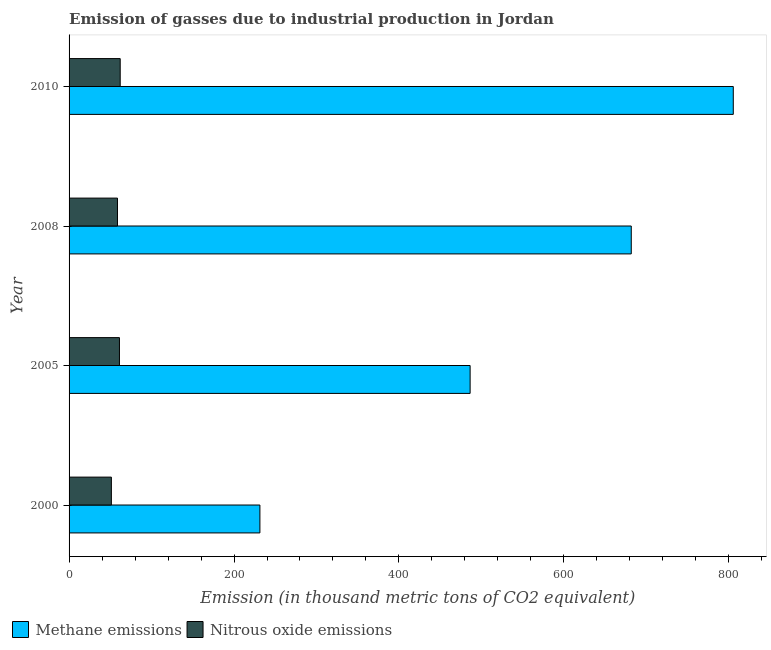How many groups of bars are there?
Your answer should be very brief. 4. Are the number of bars per tick equal to the number of legend labels?
Offer a terse response. Yes. How many bars are there on the 4th tick from the bottom?
Keep it short and to the point. 2. In how many cases, is the number of bars for a given year not equal to the number of legend labels?
Your answer should be compact. 0. What is the amount of methane emissions in 2000?
Your answer should be very brief. 231.4. Across all years, what is the maximum amount of nitrous oxide emissions?
Ensure brevity in your answer.  62. Across all years, what is the minimum amount of methane emissions?
Offer a terse response. 231.4. In which year was the amount of nitrous oxide emissions maximum?
Ensure brevity in your answer.  2010. What is the total amount of nitrous oxide emissions in the graph?
Your response must be concise. 233.1. What is the difference between the amount of nitrous oxide emissions in 2008 and the amount of methane emissions in 2010?
Provide a succinct answer. -746.7. What is the average amount of nitrous oxide emissions per year?
Give a very brief answer. 58.27. In the year 2005, what is the difference between the amount of nitrous oxide emissions and amount of methane emissions?
Your answer should be compact. -425.2. In how many years, is the amount of nitrous oxide emissions greater than 600 thousand metric tons?
Provide a succinct answer. 0. What is the ratio of the amount of methane emissions in 2005 to that in 2008?
Your answer should be compact. 0.71. Is the difference between the amount of methane emissions in 2000 and 2008 greater than the difference between the amount of nitrous oxide emissions in 2000 and 2008?
Your response must be concise. No. What is the difference between the highest and the lowest amount of methane emissions?
Your answer should be very brief. 574. In how many years, is the amount of methane emissions greater than the average amount of methane emissions taken over all years?
Your answer should be very brief. 2. Is the sum of the amount of nitrous oxide emissions in 2005 and 2008 greater than the maximum amount of methane emissions across all years?
Your response must be concise. No. What does the 1st bar from the top in 2005 represents?
Provide a succinct answer. Nitrous oxide emissions. What does the 2nd bar from the bottom in 2000 represents?
Provide a succinct answer. Nitrous oxide emissions. What is the difference between two consecutive major ticks on the X-axis?
Your response must be concise. 200. Does the graph contain any zero values?
Your answer should be very brief. No. How many legend labels are there?
Provide a short and direct response. 2. What is the title of the graph?
Offer a terse response. Emission of gasses due to industrial production in Jordan. Does "Chemicals" appear as one of the legend labels in the graph?
Your answer should be very brief. No. What is the label or title of the X-axis?
Your response must be concise. Emission (in thousand metric tons of CO2 equivalent). What is the Emission (in thousand metric tons of CO2 equivalent) of Methane emissions in 2000?
Offer a terse response. 231.4. What is the Emission (in thousand metric tons of CO2 equivalent) of Nitrous oxide emissions in 2000?
Offer a very short reply. 51.3. What is the Emission (in thousand metric tons of CO2 equivalent) of Methane emissions in 2005?
Give a very brief answer. 486.3. What is the Emission (in thousand metric tons of CO2 equivalent) in Nitrous oxide emissions in 2005?
Offer a very short reply. 61.1. What is the Emission (in thousand metric tons of CO2 equivalent) in Methane emissions in 2008?
Offer a very short reply. 681.7. What is the Emission (in thousand metric tons of CO2 equivalent) of Nitrous oxide emissions in 2008?
Your response must be concise. 58.7. What is the Emission (in thousand metric tons of CO2 equivalent) of Methane emissions in 2010?
Your answer should be very brief. 805.4. What is the Emission (in thousand metric tons of CO2 equivalent) of Nitrous oxide emissions in 2010?
Your answer should be very brief. 62. Across all years, what is the maximum Emission (in thousand metric tons of CO2 equivalent) in Methane emissions?
Make the answer very short. 805.4. Across all years, what is the minimum Emission (in thousand metric tons of CO2 equivalent) of Methane emissions?
Ensure brevity in your answer.  231.4. Across all years, what is the minimum Emission (in thousand metric tons of CO2 equivalent) of Nitrous oxide emissions?
Your answer should be compact. 51.3. What is the total Emission (in thousand metric tons of CO2 equivalent) of Methane emissions in the graph?
Your response must be concise. 2204.8. What is the total Emission (in thousand metric tons of CO2 equivalent) of Nitrous oxide emissions in the graph?
Your response must be concise. 233.1. What is the difference between the Emission (in thousand metric tons of CO2 equivalent) of Methane emissions in 2000 and that in 2005?
Offer a very short reply. -254.9. What is the difference between the Emission (in thousand metric tons of CO2 equivalent) of Nitrous oxide emissions in 2000 and that in 2005?
Keep it short and to the point. -9.8. What is the difference between the Emission (in thousand metric tons of CO2 equivalent) in Methane emissions in 2000 and that in 2008?
Make the answer very short. -450.3. What is the difference between the Emission (in thousand metric tons of CO2 equivalent) in Methane emissions in 2000 and that in 2010?
Ensure brevity in your answer.  -574. What is the difference between the Emission (in thousand metric tons of CO2 equivalent) in Methane emissions in 2005 and that in 2008?
Keep it short and to the point. -195.4. What is the difference between the Emission (in thousand metric tons of CO2 equivalent) in Methane emissions in 2005 and that in 2010?
Provide a succinct answer. -319.1. What is the difference between the Emission (in thousand metric tons of CO2 equivalent) in Nitrous oxide emissions in 2005 and that in 2010?
Your answer should be very brief. -0.9. What is the difference between the Emission (in thousand metric tons of CO2 equivalent) of Methane emissions in 2008 and that in 2010?
Make the answer very short. -123.7. What is the difference between the Emission (in thousand metric tons of CO2 equivalent) in Methane emissions in 2000 and the Emission (in thousand metric tons of CO2 equivalent) in Nitrous oxide emissions in 2005?
Your response must be concise. 170.3. What is the difference between the Emission (in thousand metric tons of CO2 equivalent) of Methane emissions in 2000 and the Emission (in thousand metric tons of CO2 equivalent) of Nitrous oxide emissions in 2008?
Make the answer very short. 172.7. What is the difference between the Emission (in thousand metric tons of CO2 equivalent) in Methane emissions in 2000 and the Emission (in thousand metric tons of CO2 equivalent) in Nitrous oxide emissions in 2010?
Give a very brief answer. 169.4. What is the difference between the Emission (in thousand metric tons of CO2 equivalent) in Methane emissions in 2005 and the Emission (in thousand metric tons of CO2 equivalent) in Nitrous oxide emissions in 2008?
Ensure brevity in your answer.  427.6. What is the difference between the Emission (in thousand metric tons of CO2 equivalent) in Methane emissions in 2005 and the Emission (in thousand metric tons of CO2 equivalent) in Nitrous oxide emissions in 2010?
Make the answer very short. 424.3. What is the difference between the Emission (in thousand metric tons of CO2 equivalent) in Methane emissions in 2008 and the Emission (in thousand metric tons of CO2 equivalent) in Nitrous oxide emissions in 2010?
Ensure brevity in your answer.  619.7. What is the average Emission (in thousand metric tons of CO2 equivalent) of Methane emissions per year?
Ensure brevity in your answer.  551.2. What is the average Emission (in thousand metric tons of CO2 equivalent) of Nitrous oxide emissions per year?
Your response must be concise. 58.27. In the year 2000, what is the difference between the Emission (in thousand metric tons of CO2 equivalent) of Methane emissions and Emission (in thousand metric tons of CO2 equivalent) of Nitrous oxide emissions?
Your answer should be compact. 180.1. In the year 2005, what is the difference between the Emission (in thousand metric tons of CO2 equivalent) in Methane emissions and Emission (in thousand metric tons of CO2 equivalent) in Nitrous oxide emissions?
Offer a terse response. 425.2. In the year 2008, what is the difference between the Emission (in thousand metric tons of CO2 equivalent) in Methane emissions and Emission (in thousand metric tons of CO2 equivalent) in Nitrous oxide emissions?
Offer a very short reply. 623. In the year 2010, what is the difference between the Emission (in thousand metric tons of CO2 equivalent) of Methane emissions and Emission (in thousand metric tons of CO2 equivalent) of Nitrous oxide emissions?
Your answer should be compact. 743.4. What is the ratio of the Emission (in thousand metric tons of CO2 equivalent) in Methane emissions in 2000 to that in 2005?
Provide a succinct answer. 0.48. What is the ratio of the Emission (in thousand metric tons of CO2 equivalent) of Nitrous oxide emissions in 2000 to that in 2005?
Keep it short and to the point. 0.84. What is the ratio of the Emission (in thousand metric tons of CO2 equivalent) of Methane emissions in 2000 to that in 2008?
Offer a terse response. 0.34. What is the ratio of the Emission (in thousand metric tons of CO2 equivalent) of Nitrous oxide emissions in 2000 to that in 2008?
Give a very brief answer. 0.87. What is the ratio of the Emission (in thousand metric tons of CO2 equivalent) in Methane emissions in 2000 to that in 2010?
Provide a succinct answer. 0.29. What is the ratio of the Emission (in thousand metric tons of CO2 equivalent) in Nitrous oxide emissions in 2000 to that in 2010?
Offer a very short reply. 0.83. What is the ratio of the Emission (in thousand metric tons of CO2 equivalent) of Methane emissions in 2005 to that in 2008?
Ensure brevity in your answer.  0.71. What is the ratio of the Emission (in thousand metric tons of CO2 equivalent) in Nitrous oxide emissions in 2005 to that in 2008?
Offer a terse response. 1.04. What is the ratio of the Emission (in thousand metric tons of CO2 equivalent) of Methane emissions in 2005 to that in 2010?
Offer a very short reply. 0.6. What is the ratio of the Emission (in thousand metric tons of CO2 equivalent) in Nitrous oxide emissions in 2005 to that in 2010?
Keep it short and to the point. 0.99. What is the ratio of the Emission (in thousand metric tons of CO2 equivalent) of Methane emissions in 2008 to that in 2010?
Make the answer very short. 0.85. What is the ratio of the Emission (in thousand metric tons of CO2 equivalent) in Nitrous oxide emissions in 2008 to that in 2010?
Your answer should be very brief. 0.95. What is the difference between the highest and the second highest Emission (in thousand metric tons of CO2 equivalent) in Methane emissions?
Your answer should be compact. 123.7. What is the difference between the highest and the second highest Emission (in thousand metric tons of CO2 equivalent) of Nitrous oxide emissions?
Offer a terse response. 0.9. What is the difference between the highest and the lowest Emission (in thousand metric tons of CO2 equivalent) of Methane emissions?
Give a very brief answer. 574. What is the difference between the highest and the lowest Emission (in thousand metric tons of CO2 equivalent) of Nitrous oxide emissions?
Ensure brevity in your answer.  10.7. 